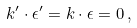Convert formula to latex. <formula><loc_0><loc_0><loc_500><loc_500>k ^ { \prime } \cdot \epsilon ^ { \prime } = k \cdot \epsilon = 0 \, ,</formula> 